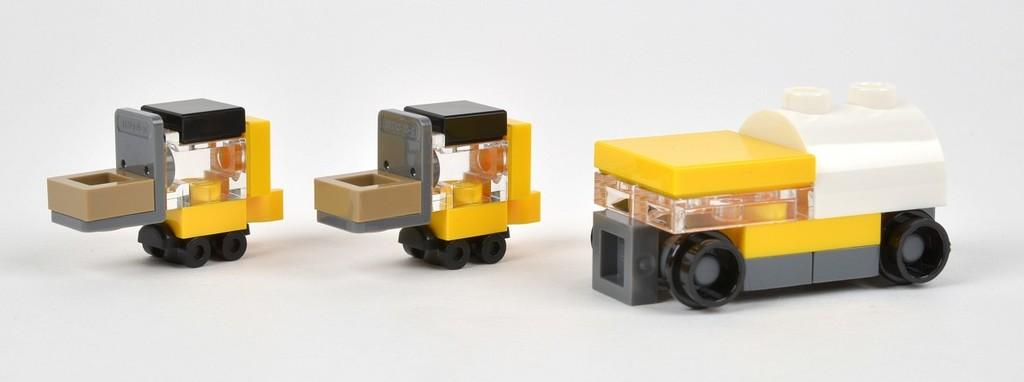What type of objects are present in the image? There are toy vehicles in the image. Where are the toy vehicles located? The toy vehicles are placed on a table. What type of air is being used to operate the toy vehicles in the image? There is no air or operation involved with the toy vehicles in the image; they are stationary and not functioning. 